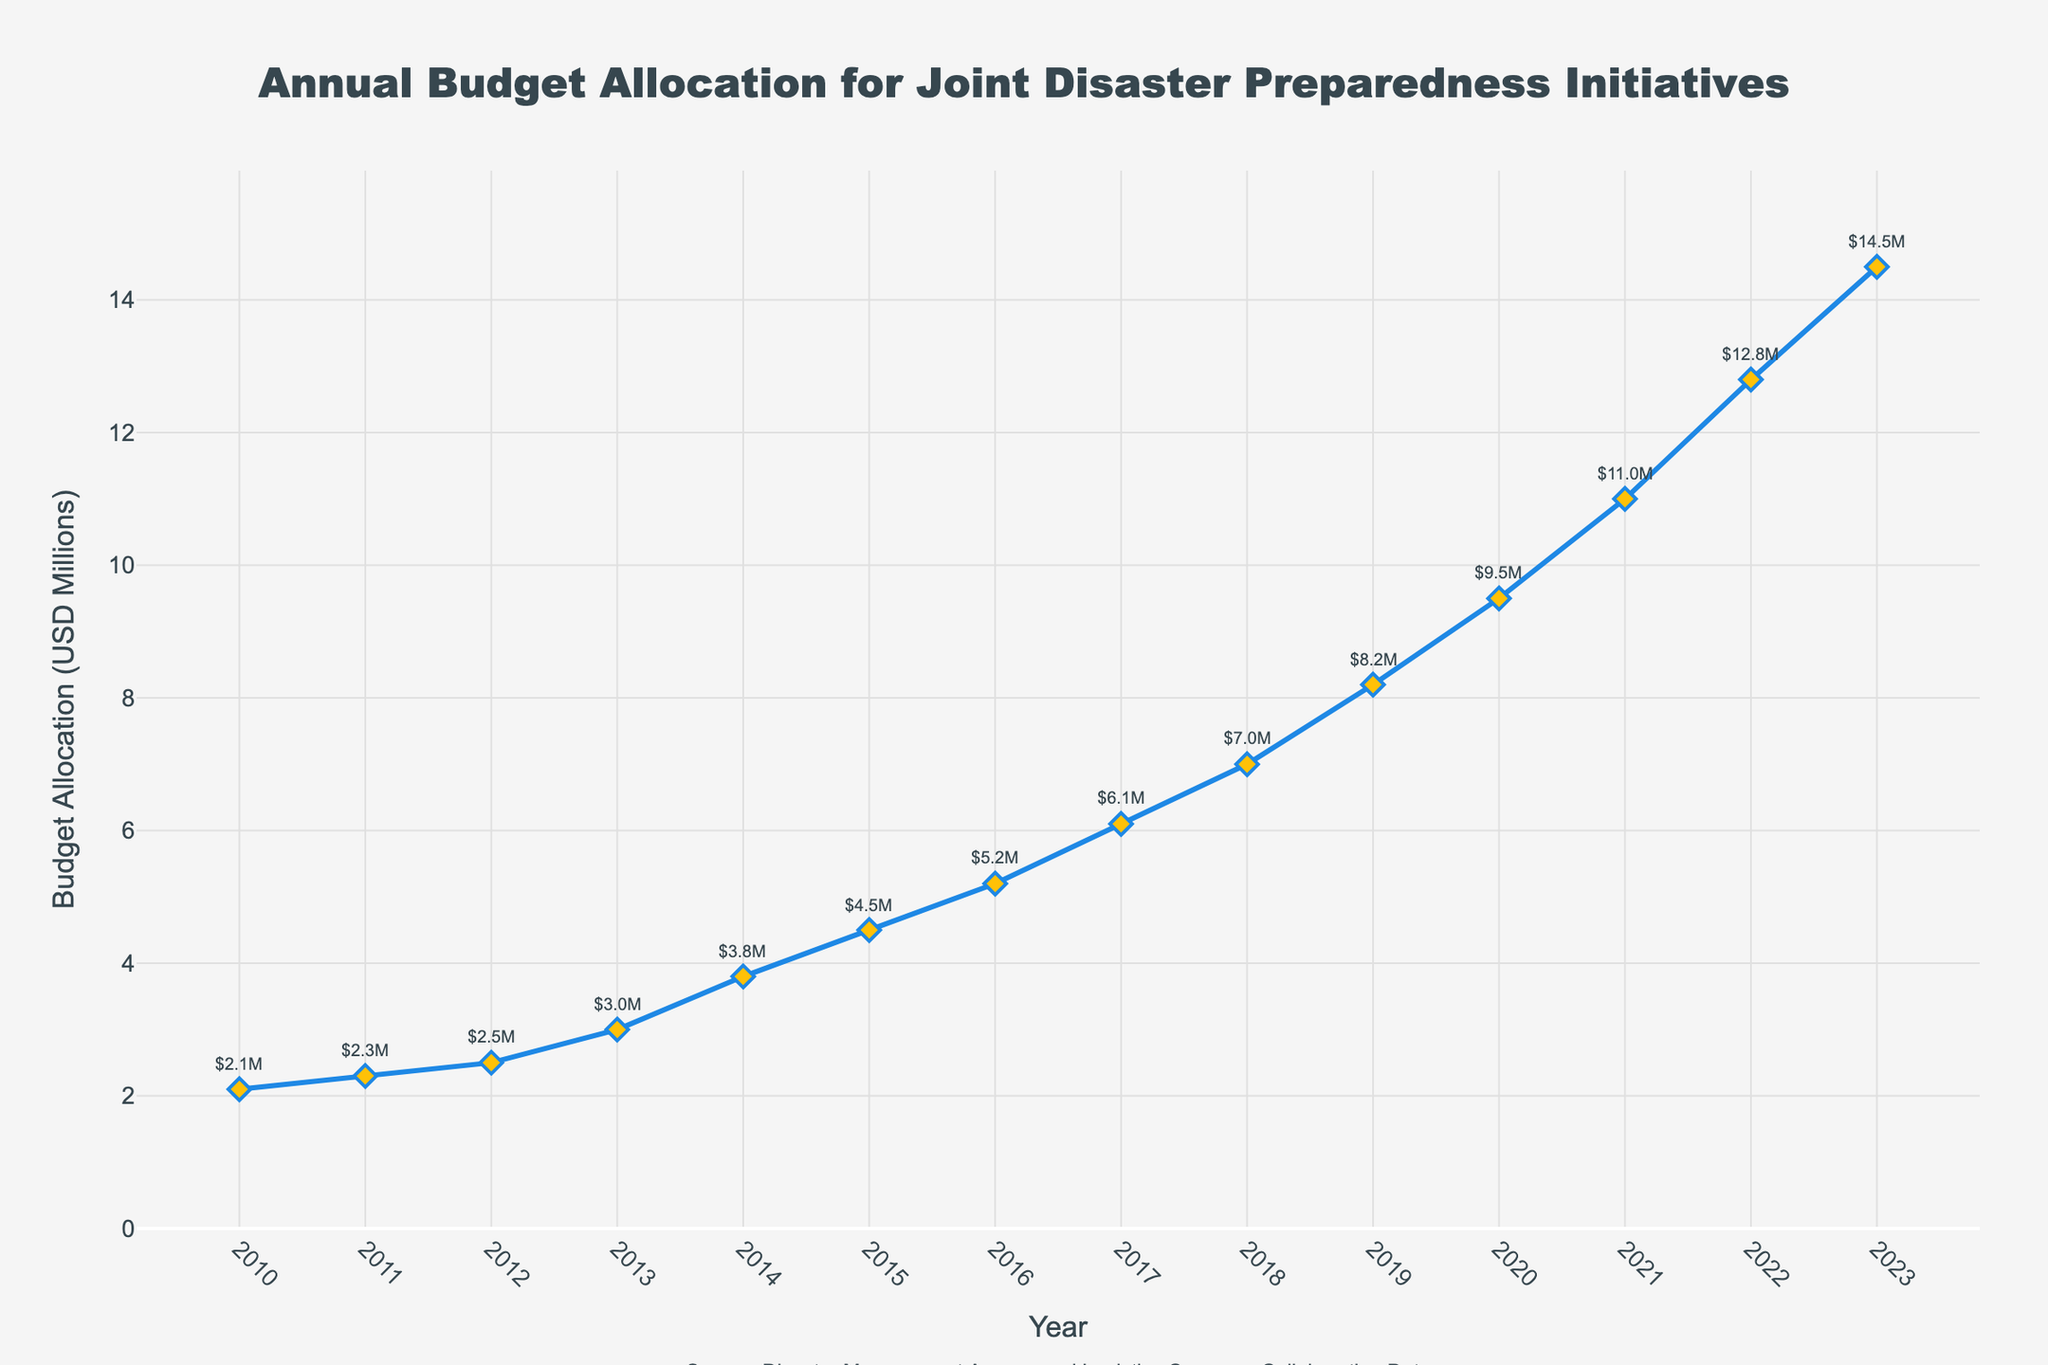What's the budget allocation in 2020? In the figure, the budget allocation for 2020 is displayed along the y-axis and marked with a text annotation as $9.5M.
Answer: $9.5M Between which consecutive years did the budget allocation increase the most? To find the largest increase between consecutive years, calculate the difference between successive years and identify the largest one. The largest increase is from 2021 to 2022 (12.8 - 11.0 = 1.8).
Answer: Between 2021 and 2022 What's the total budget allocation from 2010 to 2023? Sum up the budget allocation for each year from 2010 to 2023. (2.1 + 2.3 + 2.5 + 3.0 + 3.8 + 4.5 + 5.2 + 6.1 + 7.0 + 8.2 + 9.5 + 11.0 + 12.8 + 14.5) = 92.5.
Answer: 92.5M In which year did the budget allocation first exceed $10 million? Identify the first year where the y-axis value is greater than 10.0. According to the plot, the first budget allocation exceeding $10 million is in 2021.
Answer: 2021 How does the budget allocation change from 2018 to 2020? Determine the values from the plot for 2018, 2019, and 2020, then observe the change. From 2018 ($7.0M), it increases to $8.2M in 2019, then to $9.5M in 2020.
Answer: It increases What is the average annual budget allocation over the period 2010-2023? Calculate the sum of the budget allocations and divide by the number of years (14). Total budget sum: 92.5. Average = 92.5 / 14 ≈ 6.61M.
Answer: 6.61M Which year saw the smallest increase in budget allocation compared to the previous year? Calculate the year-over-year increases and identify the smallest one. 2010-2011: 0.2, 2011-2012: 0.2, 2012-2013: 0.5, 2013-2014: 0.8, 2014-2015: 0.7, 2015-2016: 0.7, 2016-2017: 0.9, 2017-2018: 0.9, 2018-2019: 1.2, 2019-2020: 1.3, 2020-2021: 1.5, 2021-2022: 1.8, 2022-2023: 1.7 — smallest increase is 2010-2011 and 2011-2012 (0.2).
Answer: 2010-2011 and 2011-2012 Which year's budget allocation is represented by the highest point in the line chart? The highest point on the line chart corresponds to the year with the highest budget allocation, which is the last year (2023) at $14.5M.
Answer: 2023 By how much did the budget allocation increase from 2015 to 2020? Calculate the difference between the allocations in 2020 (9.5M) and 2015 (4.5M), which is 9.5 - 4.5 = 5.0M.
Answer: 5.0M How does the color of the data points help interpret the figure? The data points are marked with yellow diamonds, which help distinguish them clearly along the plotted blue line, making it easy to follow the trend of the budget allocation.
Answer: They highlight the data points 